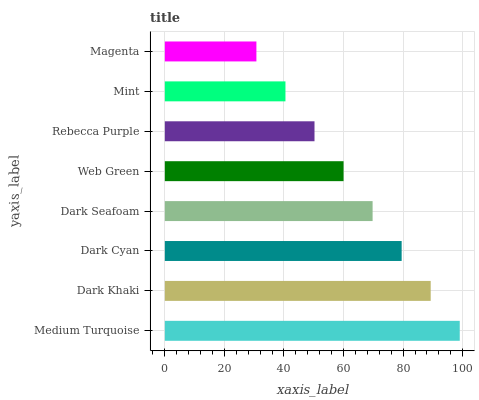Is Magenta the minimum?
Answer yes or no. Yes. Is Medium Turquoise the maximum?
Answer yes or no. Yes. Is Dark Khaki the minimum?
Answer yes or no. No. Is Dark Khaki the maximum?
Answer yes or no. No. Is Medium Turquoise greater than Dark Khaki?
Answer yes or no. Yes. Is Dark Khaki less than Medium Turquoise?
Answer yes or no. Yes. Is Dark Khaki greater than Medium Turquoise?
Answer yes or no. No. Is Medium Turquoise less than Dark Khaki?
Answer yes or no. No. Is Dark Seafoam the high median?
Answer yes or no. Yes. Is Web Green the low median?
Answer yes or no. Yes. Is Rebecca Purple the high median?
Answer yes or no. No. Is Medium Turquoise the low median?
Answer yes or no. No. 